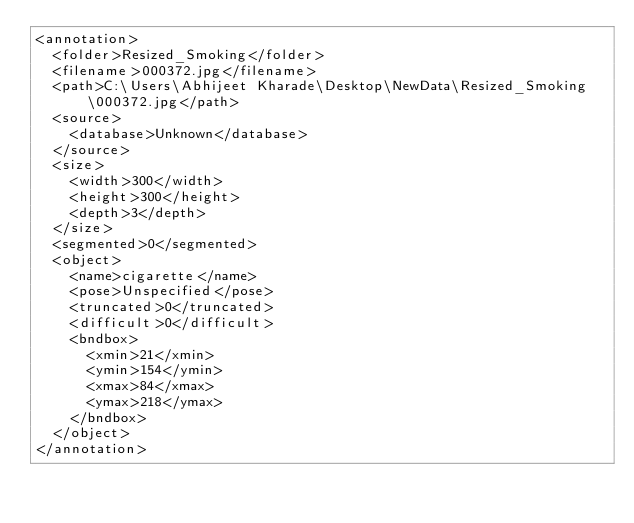Convert code to text. <code><loc_0><loc_0><loc_500><loc_500><_XML_><annotation>
	<folder>Resized_Smoking</folder>
	<filename>000372.jpg</filename>
	<path>C:\Users\Abhijeet Kharade\Desktop\NewData\Resized_Smoking\000372.jpg</path>
	<source>
		<database>Unknown</database>
	</source>
	<size>
		<width>300</width>
		<height>300</height>
		<depth>3</depth>
	</size>
	<segmented>0</segmented>
	<object>
		<name>cigarette</name>
		<pose>Unspecified</pose>
		<truncated>0</truncated>
		<difficult>0</difficult>
		<bndbox>
			<xmin>21</xmin>
			<ymin>154</ymin>
			<xmax>84</xmax>
			<ymax>218</ymax>
		</bndbox>
	</object>
</annotation>
</code> 